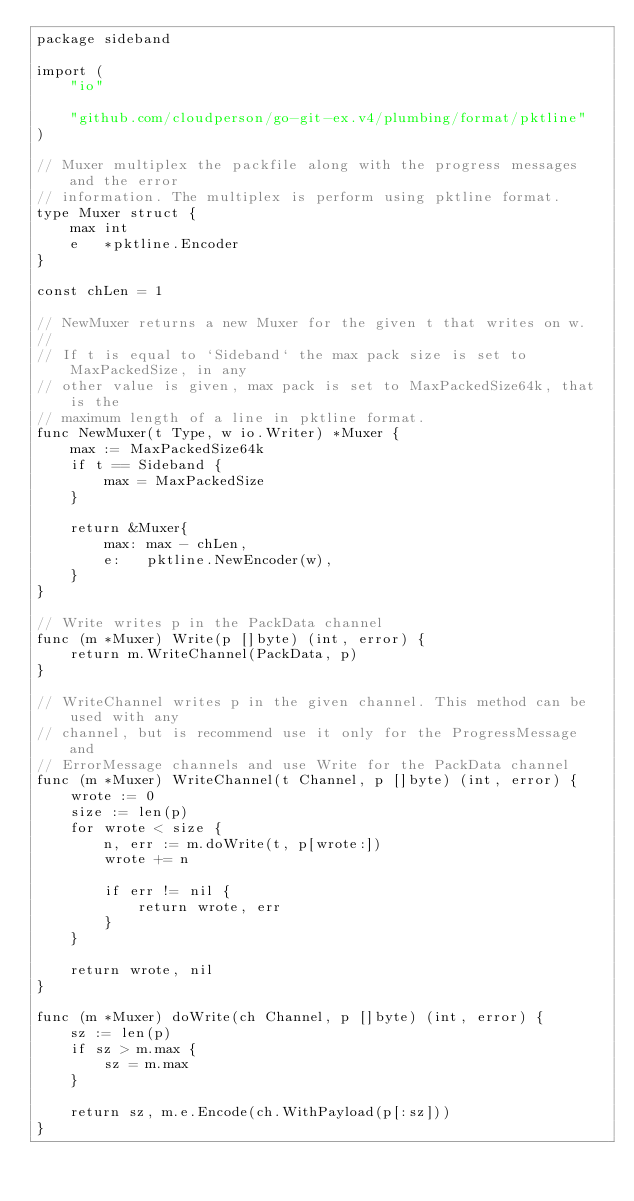Convert code to text. <code><loc_0><loc_0><loc_500><loc_500><_Go_>package sideband

import (
	"io"

	"github.com/cloudperson/go-git-ex.v4/plumbing/format/pktline"
)

// Muxer multiplex the packfile along with the progress messages and the error
// information. The multiplex is perform using pktline format.
type Muxer struct {
	max int
	e   *pktline.Encoder
}

const chLen = 1

// NewMuxer returns a new Muxer for the given t that writes on w.
//
// If t is equal to `Sideband` the max pack size is set to MaxPackedSize, in any
// other value is given, max pack is set to MaxPackedSize64k, that is the
// maximum length of a line in pktline format.
func NewMuxer(t Type, w io.Writer) *Muxer {
	max := MaxPackedSize64k
	if t == Sideband {
		max = MaxPackedSize
	}

	return &Muxer{
		max: max - chLen,
		e:   pktline.NewEncoder(w),
	}
}

// Write writes p in the PackData channel
func (m *Muxer) Write(p []byte) (int, error) {
	return m.WriteChannel(PackData, p)
}

// WriteChannel writes p in the given channel. This method can be used with any
// channel, but is recommend use it only for the ProgressMessage and
// ErrorMessage channels and use Write for the PackData channel
func (m *Muxer) WriteChannel(t Channel, p []byte) (int, error) {
	wrote := 0
	size := len(p)
	for wrote < size {
		n, err := m.doWrite(t, p[wrote:])
		wrote += n

		if err != nil {
			return wrote, err
		}
	}

	return wrote, nil
}

func (m *Muxer) doWrite(ch Channel, p []byte) (int, error) {
	sz := len(p)
	if sz > m.max {
		sz = m.max
	}

	return sz, m.e.Encode(ch.WithPayload(p[:sz]))
}
</code> 